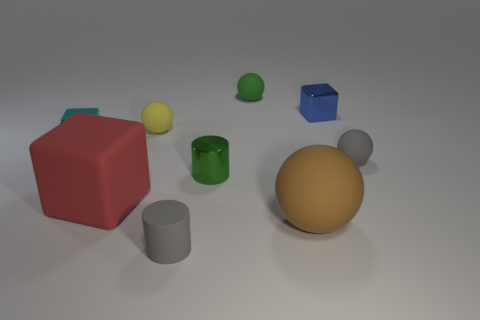Can you comment on the lighting and shadows? In this scene, the lighting appears to come from the upper left, as indicated by the shadows cast towards the right. There is a soft, diffused light that creates gentle shadows and suggests an ambient light source, rather than direct lighting like sunlight. This implies an indoor setting with either professional lighting or a cloudy daylight situation. 